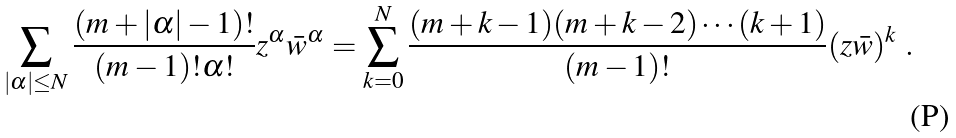<formula> <loc_0><loc_0><loc_500><loc_500>\sum _ { | \alpha | \leq N } \frac { ( m + | \alpha | - 1 ) ! } { ( m - 1 ) ! \alpha ! } z ^ { \alpha } \bar { w } ^ { \alpha } & = \sum _ { k = 0 } ^ { N } \frac { ( m + k - 1 ) ( m + k - 2 ) \cdots ( k + 1 ) } { ( m - 1 ) ! } ( z \bar { w } ) ^ { k } \ .</formula> 